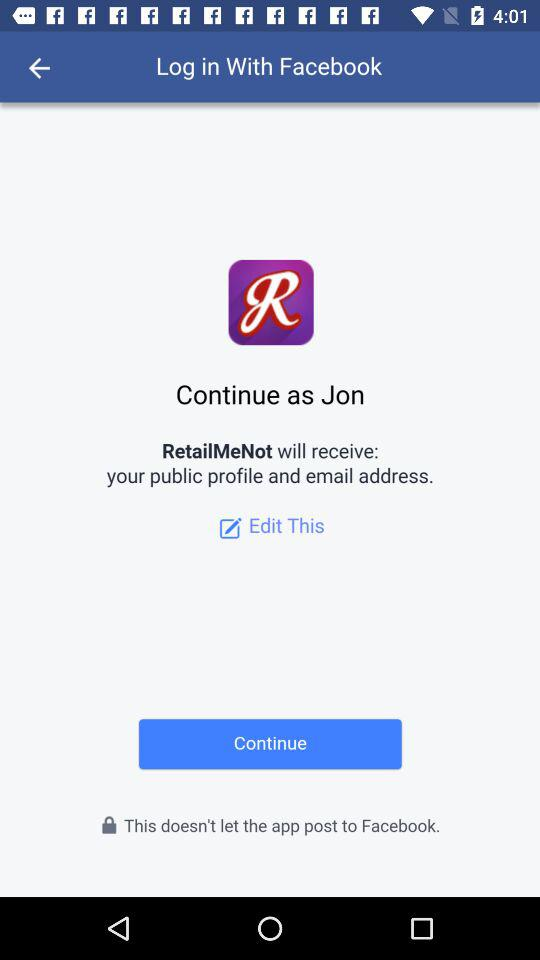What is the name of the user? The name of the user is Jon. 